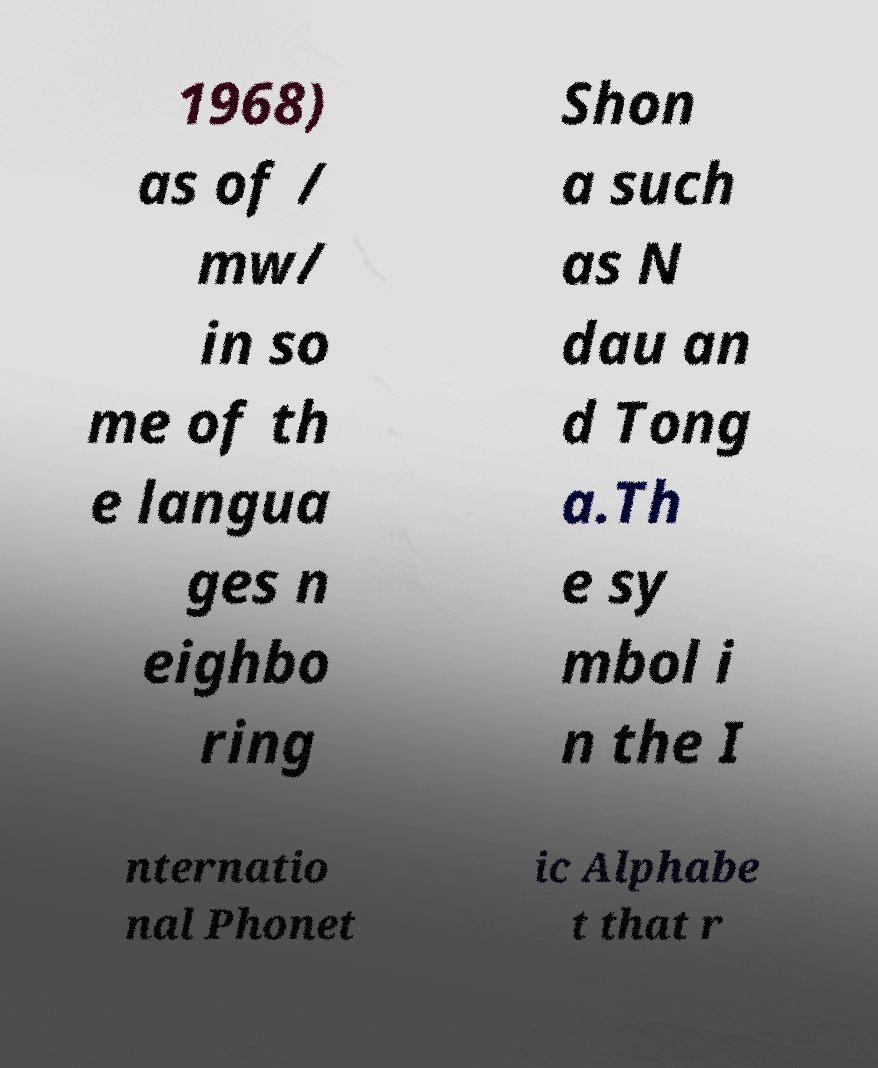What messages or text are displayed in this image? I need them in a readable, typed format. 1968) as of / mw/ in so me of th e langua ges n eighbo ring Shon a such as N dau an d Tong a.Th e sy mbol i n the I nternatio nal Phonet ic Alphabe t that r 